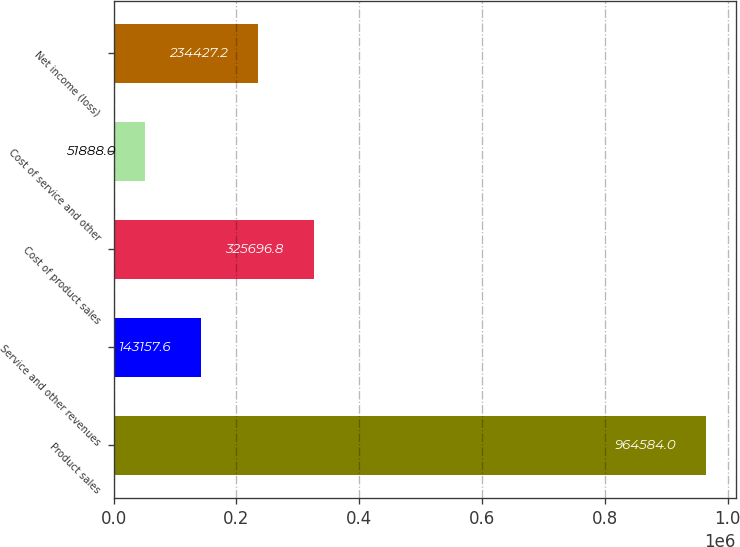Convert chart to OTSL. <chart><loc_0><loc_0><loc_500><loc_500><bar_chart><fcel>Product sales<fcel>Service and other revenues<fcel>Cost of product sales<fcel>Cost of service and other<fcel>Net income (loss)<nl><fcel>964584<fcel>143158<fcel>325697<fcel>51888<fcel>234427<nl></chart> 